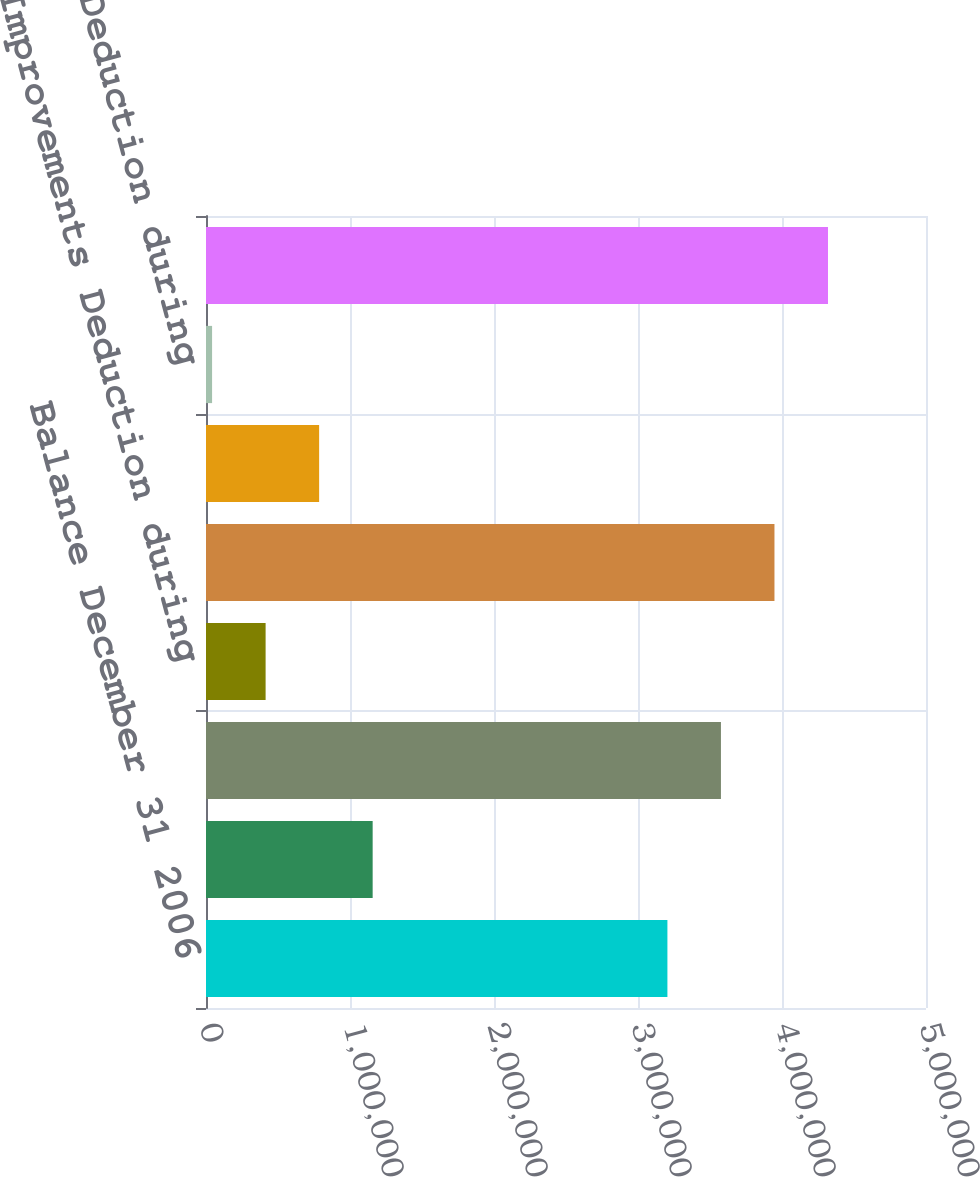Convert chart to OTSL. <chart><loc_0><loc_0><loc_500><loc_500><bar_chart><fcel>Balance December 31 2006<fcel>Acquisitions<fcel>Additions during period<fcel>Improvements Deduction during<fcel>Balance December 31 2008<fcel>Improvements<fcel>Deduction during<fcel>Balance December 31 2009<nl><fcel>3.20426e+06<fcel>1.15734e+06<fcel>3.57596e+06<fcel>413939<fcel>3.94766e+06<fcel>785639<fcel>42240<fcel>4.31936e+06<nl></chart> 